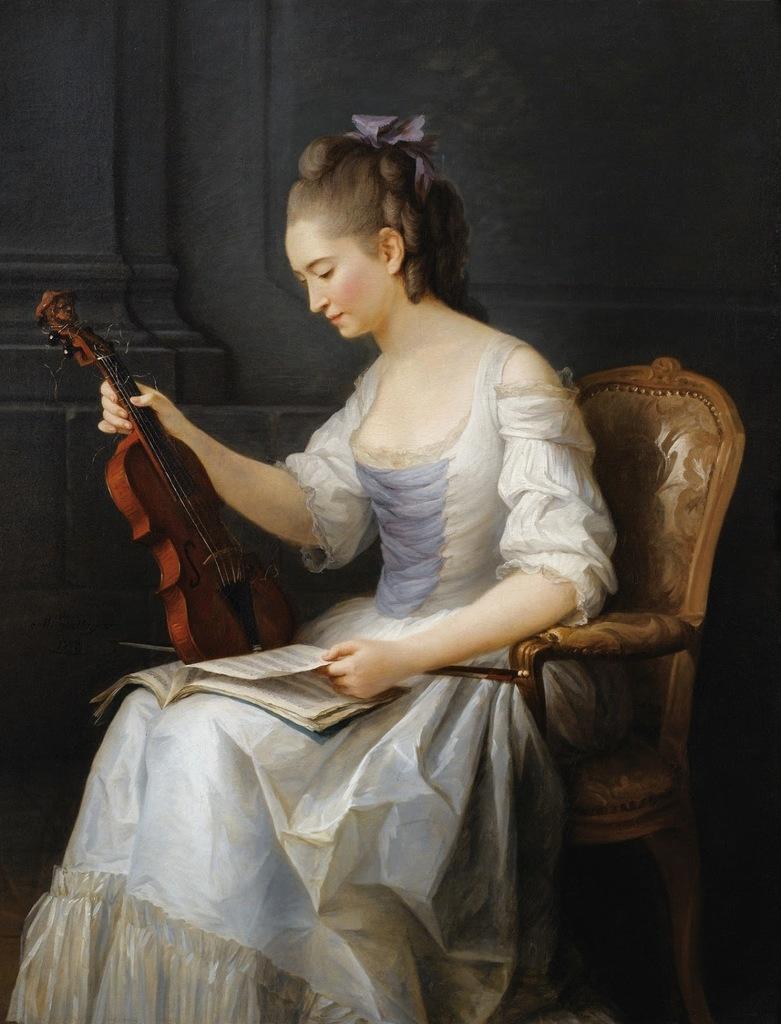Describe this image in one or two sentences. In this image we can see a lady sitting on the chair and holding a book and a violin. In the background there is a wall. 